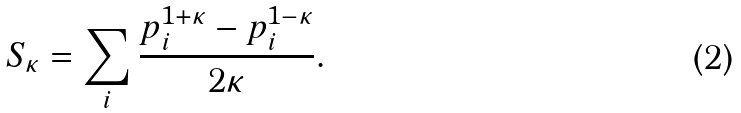<formula> <loc_0><loc_0><loc_500><loc_500>S _ { \kappa } = \sum _ { i } \frac { p _ { i } ^ { 1 + \kappa } - p _ { i } ^ { 1 - \kappa } } { 2 \kappa } .</formula> 